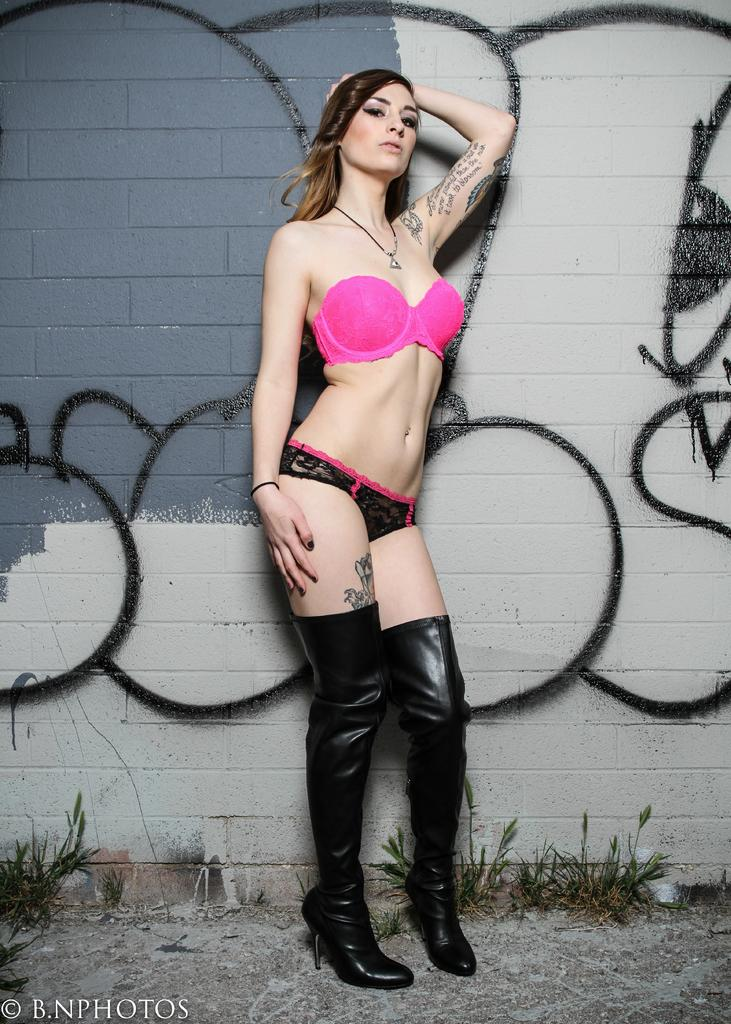Who is present in the image? There is a woman in the image. What is the woman's location in the image? The woman is standing on land in the image. What type of vegetation can be seen in the image? There are plants in the image. What can be seen in the background of the image? There is a wall in the background of the image. What type of straw is the woman using to order a drink in the image? There is no straw or drink present in the image, and therefore no such activity can be observed. 